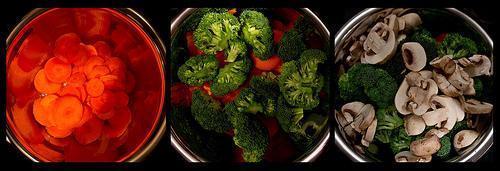How many pictures are there?
Give a very brief answer. 3. How many of the bowls in the image contain mushrooms?
Give a very brief answer. 1. How many bowls in the image contain broccoli?
Give a very brief answer. 2. 